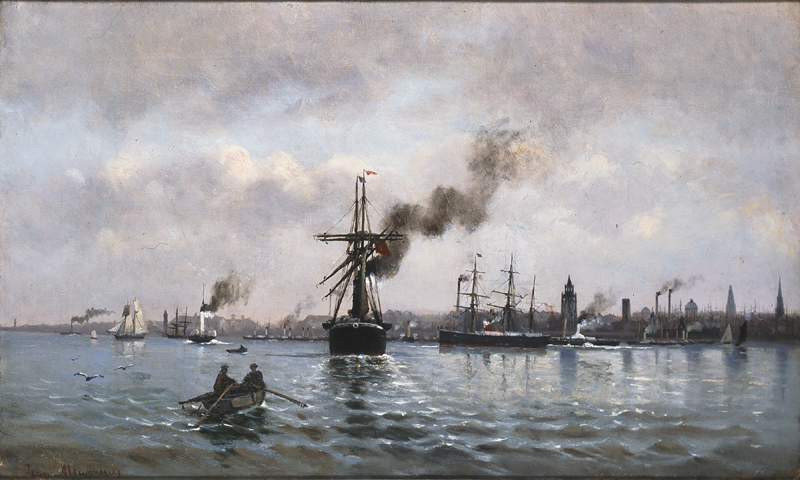What could be the economic implications of such a bustling harbor scene represented in the painting? The bustling harbor scene depicted suggests a thriving trade and maritime economy. Such activity likely indicates robust import and export operations, which could be essential for the local economy. The presence of diverse ship types, including cargo vessels and smaller boats, hints at a well-integrated maritime infrastructure, possibly crucial for the economic growth and sustenance of the region depicted. 